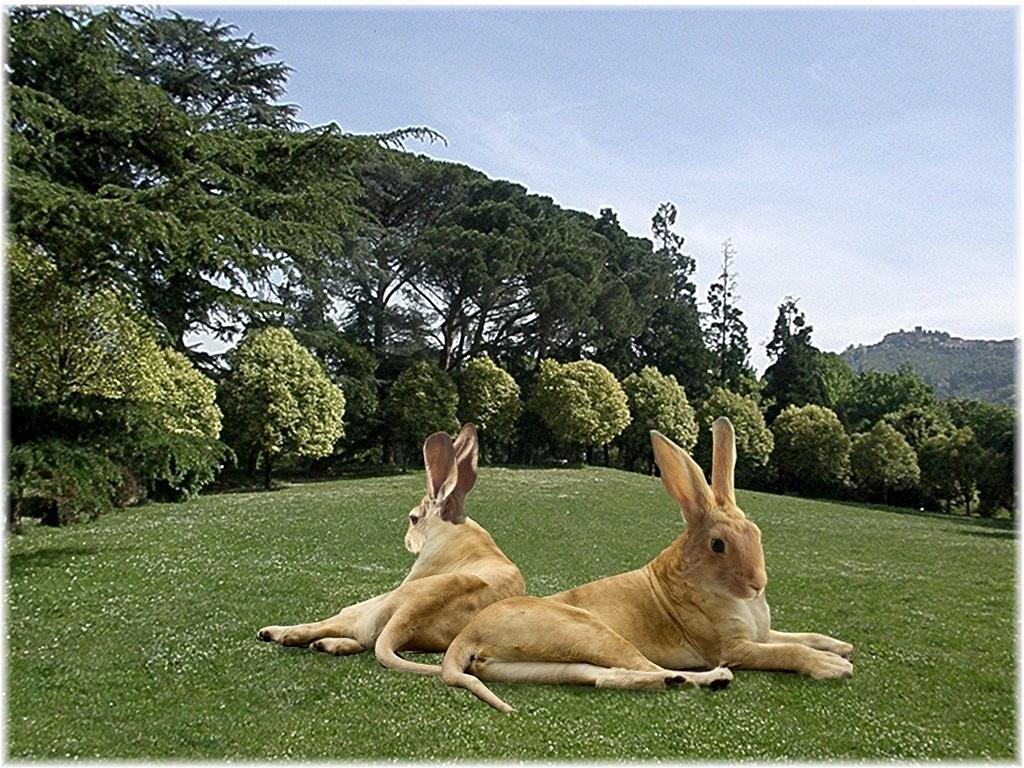Could you give a brief overview of what you see in this image? In this image I can see the animals on the grass. These are in brown and cream color. In the background I can see the many trees, mountains and the sky. 